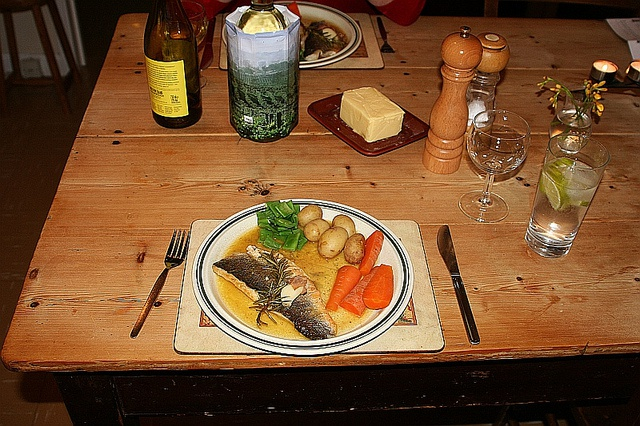Describe the objects in this image and their specific colors. I can see dining table in brown, black, maroon, and tan tones, cup in black, maroon, gray, olive, and tan tones, bottle in black, maroon, and gold tones, wine glass in black, maroon, brown, and gray tones, and carrot in black, red, brown, and salmon tones in this image. 